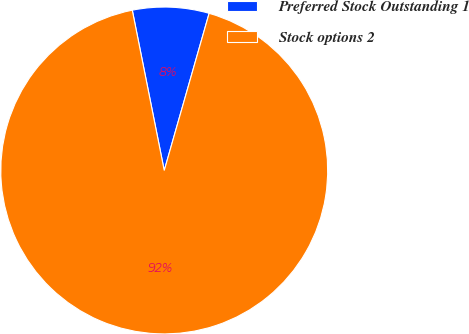Convert chart to OTSL. <chart><loc_0><loc_0><loc_500><loc_500><pie_chart><fcel>Preferred Stock Outstanding 1<fcel>Stock options 2<nl><fcel>7.56%<fcel>92.44%<nl></chart> 